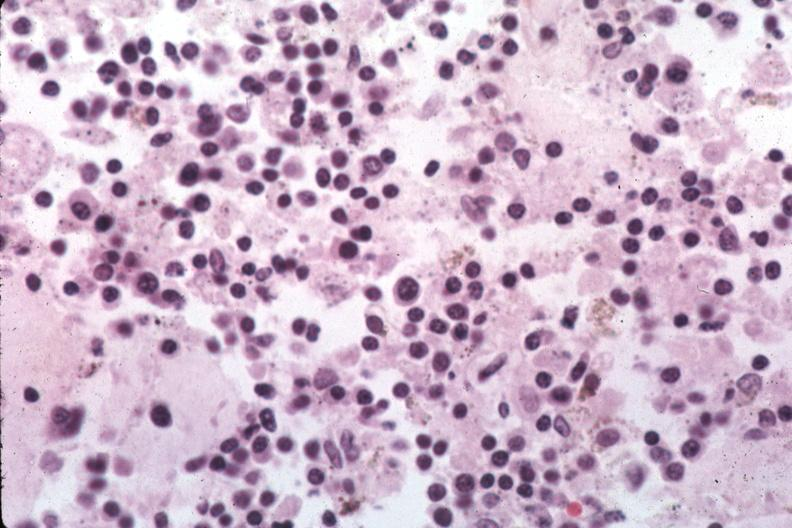s histoplasmosis present?
Answer the question using a single word or phrase. Yes 